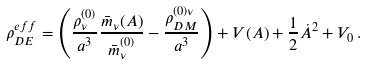Convert formula to latex. <formula><loc_0><loc_0><loc_500><loc_500>\rho _ { D E } ^ { e f f } = \left ( \frac { \rho _ { \nu } ^ { ( 0 ) } } { a ^ { 3 } } \frac { \bar { m } _ { \nu } ( A ) } { \bar { m } _ { \nu } ^ { ( 0 ) } } - \frac { \rho _ { D M } ^ { ( 0 ) \nu } } { a ^ { 3 } } \right ) + V ( A ) + \frac { 1 } { 2 } \dot { A } ^ { 2 } + V _ { 0 } \, .</formula> 